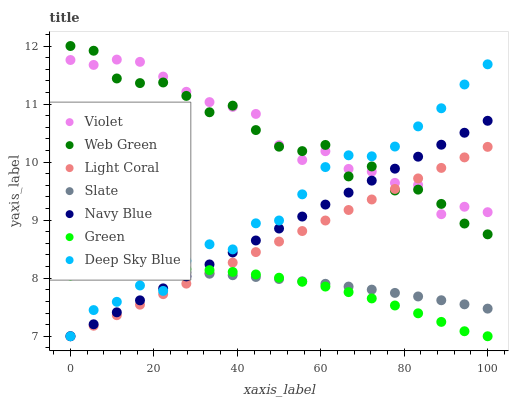Does Green have the minimum area under the curve?
Answer yes or no. Yes. Does Violet have the maximum area under the curve?
Answer yes or no. Yes. Does Slate have the minimum area under the curve?
Answer yes or no. No. Does Slate have the maximum area under the curve?
Answer yes or no. No. Is Light Coral the smoothest?
Answer yes or no. Yes. Is Web Green the roughest?
Answer yes or no. Yes. Is Slate the smoothest?
Answer yes or no. No. Is Slate the roughest?
Answer yes or no. No. Does Navy Blue have the lowest value?
Answer yes or no. Yes. Does Slate have the lowest value?
Answer yes or no. No. Does Web Green have the highest value?
Answer yes or no. Yes. Does Slate have the highest value?
Answer yes or no. No. Is Slate less than Violet?
Answer yes or no. Yes. Is Web Green greater than Slate?
Answer yes or no. Yes. Does Navy Blue intersect Green?
Answer yes or no. Yes. Is Navy Blue less than Green?
Answer yes or no. No. Is Navy Blue greater than Green?
Answer yes or no. No. Does Slate intersect Violet?
Answer yes or no. No. 